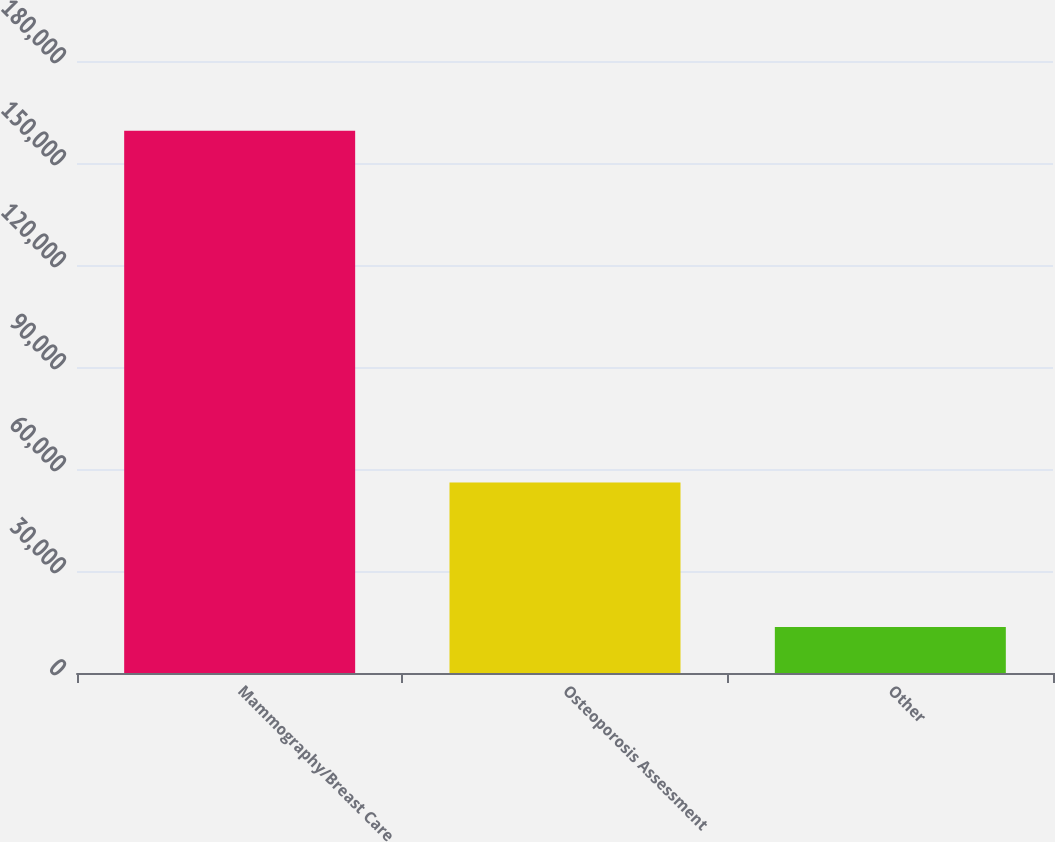Convert chart to OTSL. <chart><loc_0><loc_0><loc_500><loc_500><bar_chart><fcel>Mammography/Breast Care<fcel>Osteoporosis Assessment<fcel>Other<nl><fcel>159469<fcel>56065<fcel>13541<nl></chart> 